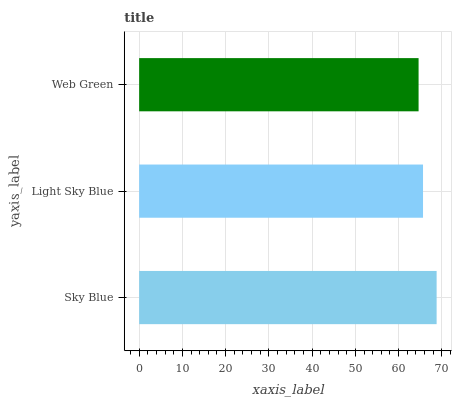Is Web Green the minimum?
Answer yes or no. Yes. Is Sky Blue the maximum?
Answer yes or no. Yes. Is Light Sky Blue the minimum?
Answer yes or no. No. Is Light Sky Blue the maximum?
Answer yes or no. No. Is Sky Blue greater than Light Sky Blue?
Answer yes or no. Yes. Is Light Sky Blue less than Sky Blue?
Answer yes or no. Yes. Is Light Sky Blue greater than Sky Blue?
Answer yes or no. No. Is Sky Blue less than Light Sky Blue?
Answer yes or no. No. Is Light Sky Blue the high median?
Answer yes or no. Yes. Is Light Sky Blue the low median?
Answer yes or no. Yes. Is Web Green the high median?
Answer yes or no. No. Is Sky Blue the low median?
Answer yes or no. No. 